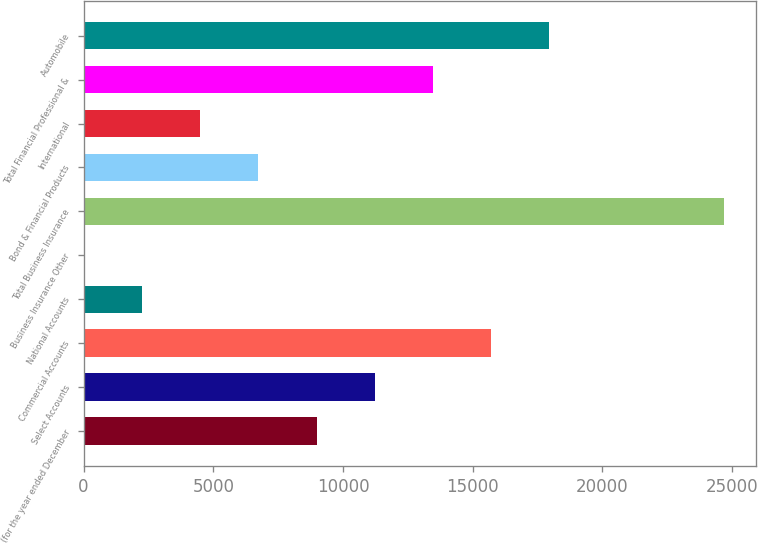<chart> <loc_0><loc_0><loc_500><loc_500><bar_chart><fcel>(for the year ended December<fcel>Select Accounts<fcel>Commercial Accounts<fcel>National Accounts<fcel>Business Insurance Other<fcel>Total Business Insurance<fcel>Bond & Financial Products<fcel>International<fcel>Total Financial Professional &<fcel>Automobile<nl><fcel>8979.4<fcel>11224<fcel>15713.2<fcel>2245.6<fcel>1<fcel>24691.6<fcel>6734.8<fcel>4490.2<fcel>13468.6<fcel>17957.8<nl></chart> 